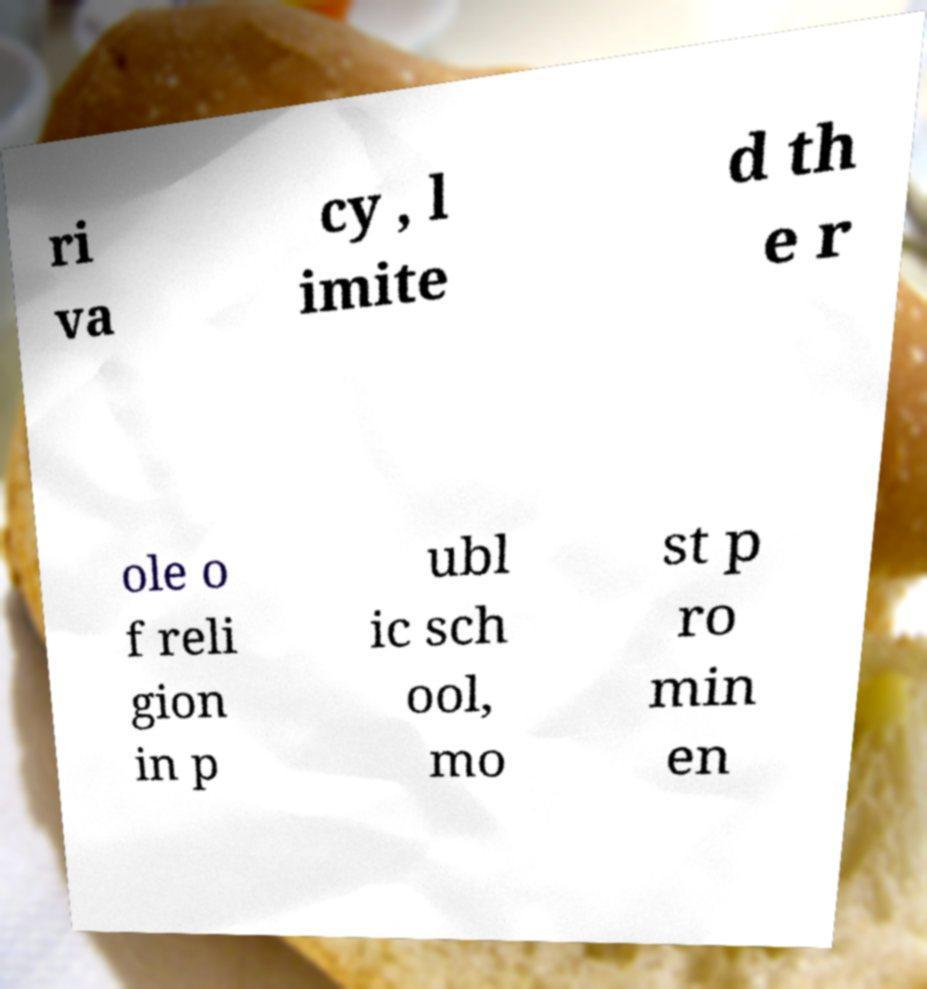Could you assist in decoding the text presented in this image and type it out clearly? ri va cy , l imite d th e r ole o f reli gion in p ubl ic sch ool, mo st p ro min en 